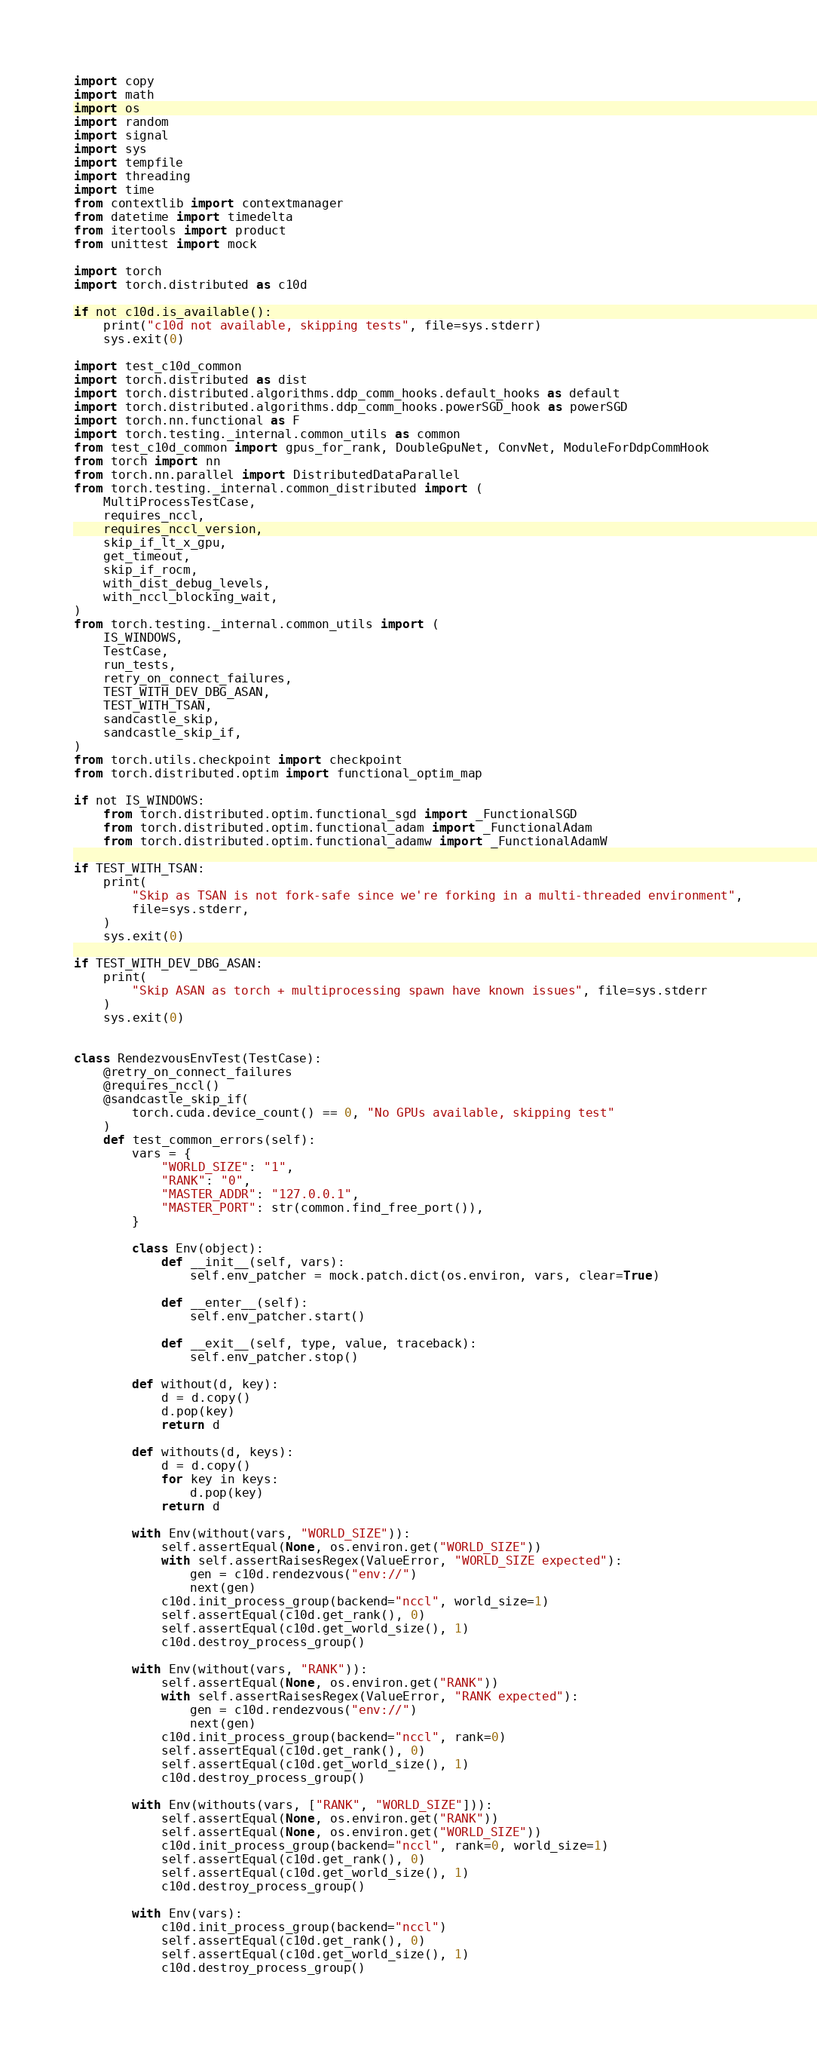Convert code to text. <code><loc_0><loc_0><loc_500><loc_500><_Python_>import copy
import math
import os
import random
import signal
import sys
import tempfile
import threading
import time
from contextlib import contextmanager
from datetime import timedelta
from itertools import product
from unittest import mock

import torch
import torch.distributed as c10d

if not c10d.is_available():
    print("c10d not available, skipping tests", file=sys.stderr)
    sys.exit(0)

import test_c10d_common
import torch.distributed as dist
import torch.distributed.algorithms.ddp_comm_hooks.default_hooks as default
import torch.distributed.algorithms.ddp_comm_hooks.powerSGD_hook as powerSGD
import torch.nn.functional as F
import torch.testing._internal.common_utils as common
from test_c10d_common import gpus_for_rank, DoubleGpuNet, ConvNet, ModuleForDdpCommHook
from torch import nn
from torch.nn.parallel import DistributedDataParallel
from torch.testing._internal.common_distributed import (
    MultiProcessTestCase,
    requires_nccl,
    requires_nccl_version,
    skip_if_lt_x_gpu,
    get_timeout,
    skip_if_rocm,
    with_dist_debug_levels,
    with_nccl_blocking_wait,
)
from torch.testing._internal.common_utils import (
    IS_WINDOWS,
    TestCase,
    run_tests,
    retry_on_connect_failures,
    TEST_WITH_DEV_DBG_ASAN,
    TEST_WITH_TSAN,
    sandcastle_skip,
    sandcastle_skip_if,
)
from torch.utils.checkpoint import checkpoint
from torch.distributed.optim import functional_optim_map

if not IS_WINDOWS:
    from torch.distributed.optim.functional_sgd import _FunctionalSGD
    from torch.distributed.optim.functional_adam import _FunctionalAdam
    from torch.distributed.optim.functional_adamw import _FunctionalAdamW

if TEST_WITH_TSAN:
    print(
        "Skip as TSAN is not fork-safe since we're forking in a multi-threaded environment",
        file=sys.stderr,
    )
    sys.exit(0)

if TEST_WITH_DEV_DBG_ASAN:
    print(
        "Skip ASAN as torch + multiprocessing spawn have known issues", file=sys.stderr
    )
    sys.exit(0)


class RendezvousEnvTest(TestCase):
    @retry_on_connect_failures
    @requires_nccl()
    @sandcastle_skip_if(
        torch.cuda.device_count() == 0, "No GPUs available, skipping test"
    )
    def test_common_errors(self):
        vars = {
            "WORLD_SIZE": "1",
            "RANK": "0",
            "MASTER_ADDR": "127.0.0.1",
            "MASTER_PORT": str(common.find_free_port()),
        }

        class Env(object):
            def __init__(self, vars):
                self.env_patcher = mock.patch.dict(os.environ, vars, clear=True)

            def __enter__(self):
                self.env_patcher.start()

            def __exit__(self, type, value, traceback):
                self.env_patcher.stop()

        def without(d, key):
            d = d.copy()
            d.pop(key)
            return d

        def withouts(d, keys):
            d = d.copy()
            for key in keys:
                d.pop(key)
            return d

        with Env(without(vars, "WORLD_SIZE")):
            self.assertEqual(None, os.environ.get("WORLD_SIZE"))
            with self.assertRaisesRegex(ValueError, "WORLD_SIZE expected"):
                gen = c10d.rendezvous("env://")
                next(gen)
            c10d.init_process_group(backend="nccl", world_size=1)
            self.assertEqual(c10d.get_rank(), 0)
            self.assertEqual(c10d.get_world_size(), 1)
            c10d.destroy_process_group()

        with Env(without(vars, "RANK")):
            self.assertEqual(None, os.environ.get("RANK"))
            with self.assertRaisesRegex(ValueError, "RANK expected"):
                gen = c10d.rendezvous("env://")
                next(gen)
            c10d.init_process_group(backend="nccl", rank=0)
            self.assertEqual(c10d.get_rank(), 0)
            self.assertEqual(c10d.get_world_size(), 1)
            c10d.destroy_process_group()

        with Env(withouts(vars, ["RANK", "WORLD_SIZE"])):
            self.assertEqual(None, os.environ.get("RANK"))
            self.assertEqual(None, os.environ.get("WORLD_SIZE"))
            c10d.init_process_group(backend="nccl", rank=0, world_size=1)
            self.assertEqual(c10d.get_rank(), 0)
            self.assertEqual(c10d.get_world_size(), 1)
            c10d.destroy_process_group()

        with Env(vars):
            c10d.init_process_group(backend="nccl")
            self.assertEqual(c10d.get_rank(), 0)
            self.assertEqual(c10d.get_world_size(), 1)
            c10d.destroy_process_group()
</code> 